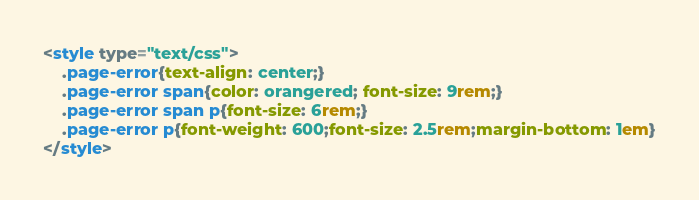<code> <loc_0><loc_0><loc_500><loc_500><_HTML_><style type="text/css">
    .page-error{text-align: center;}
    .page-error span{color: orangered; font-size: 9rem;}
    .page-error span p{font-size: 6rem;}
    .page-error p{font-weight: 600;font-size: 2.5rem;margin-bottom: 1em}
</style>


</code> 